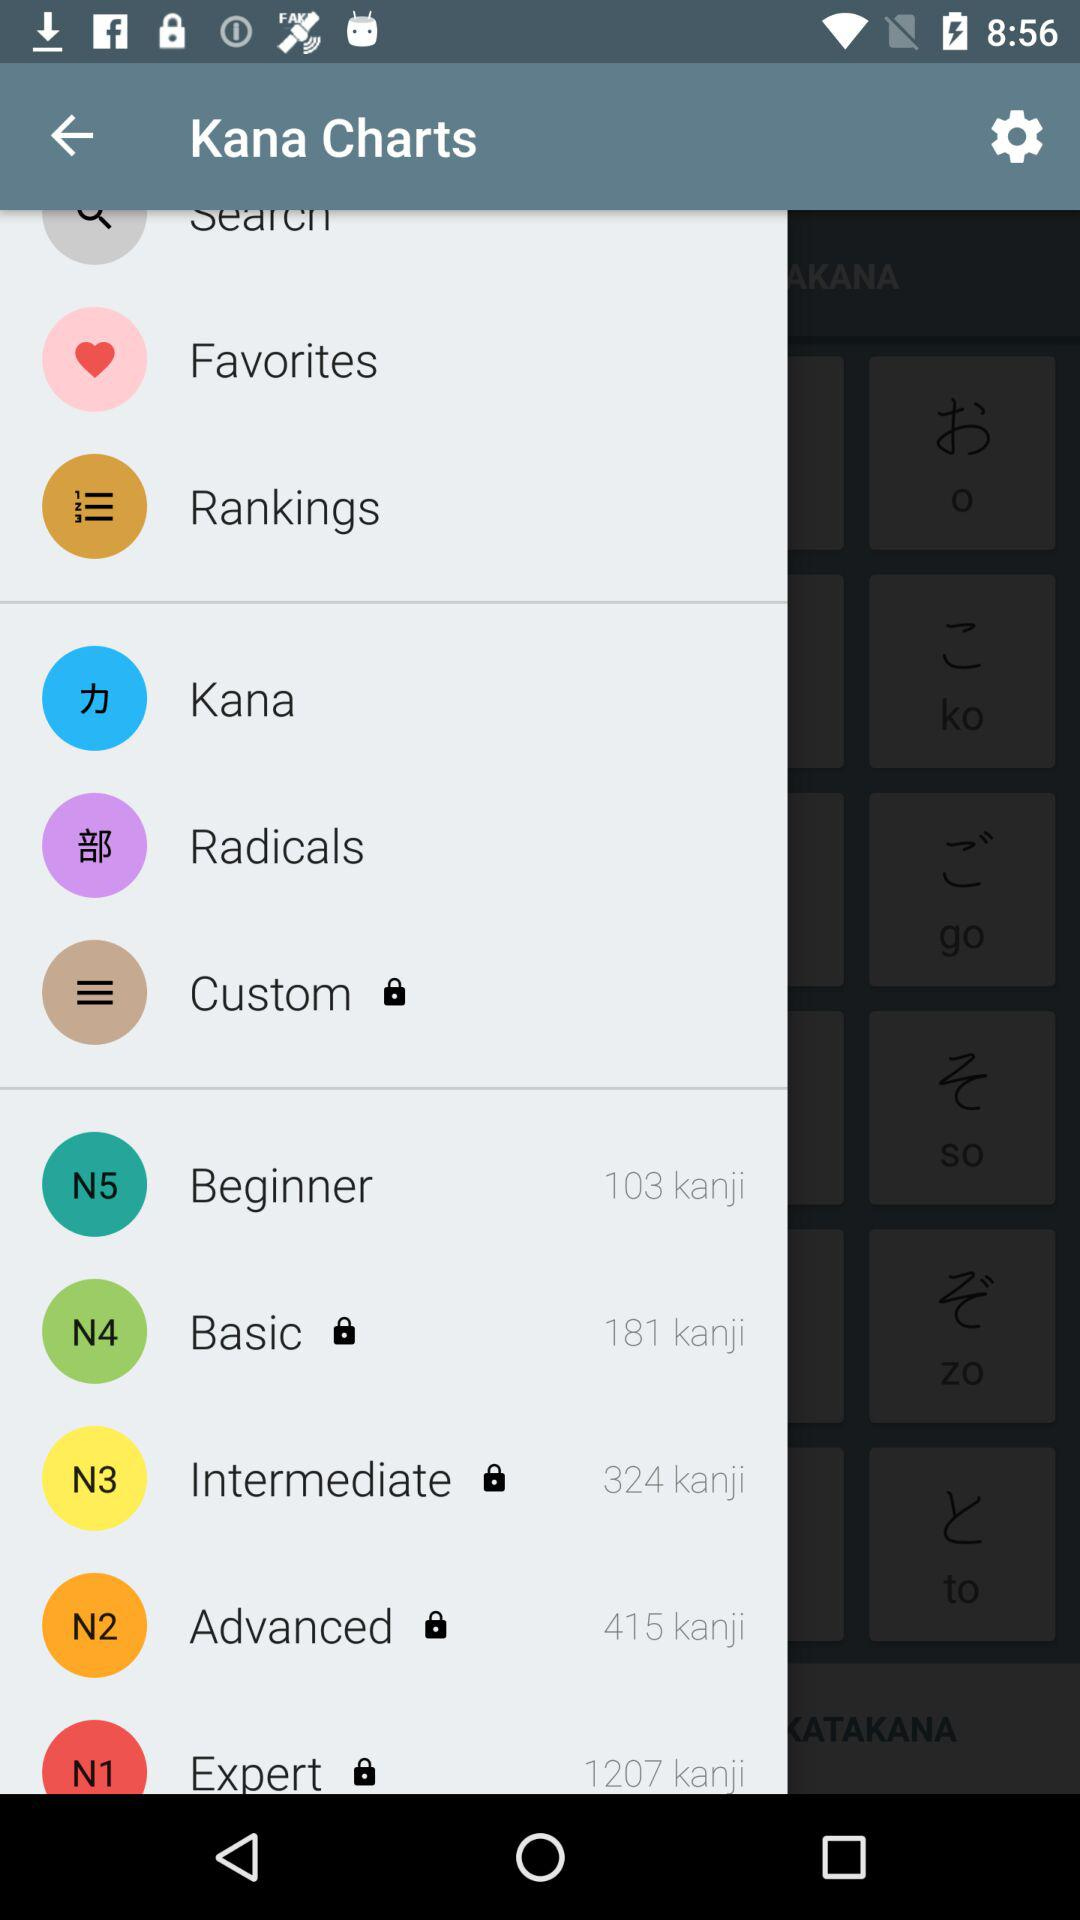How many kanji are in the 'Expert' level?
Answer the question using a single word or phrase. 1207 